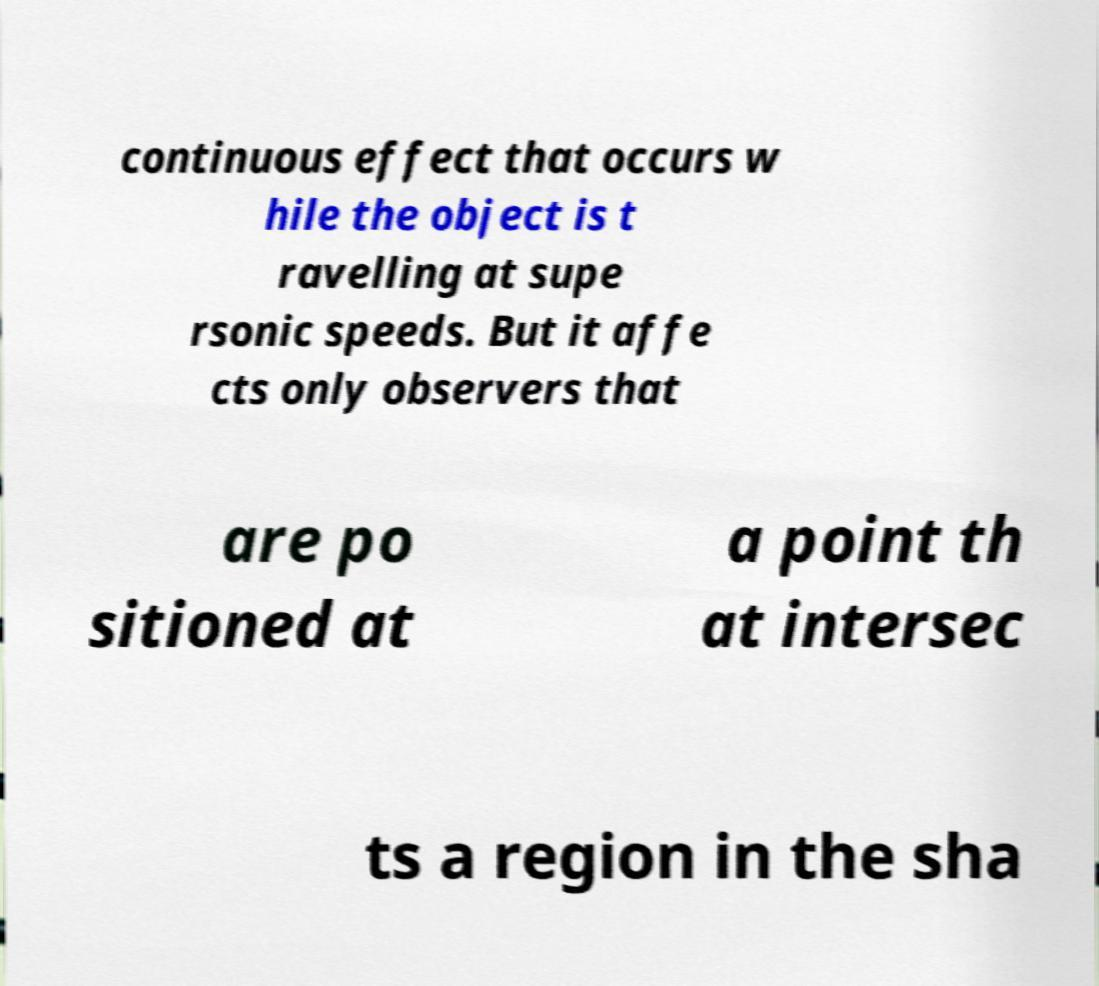Can you read and provide the text displayed in the image?This photo seems to have some interesting text. Can you extract and type it out for me? continuous effect that occurs w hile the object is t ravelling at supe rsonic speeds. But it affe cts only observers that are po sitioned at a point th at intersec ts a region in the sha 